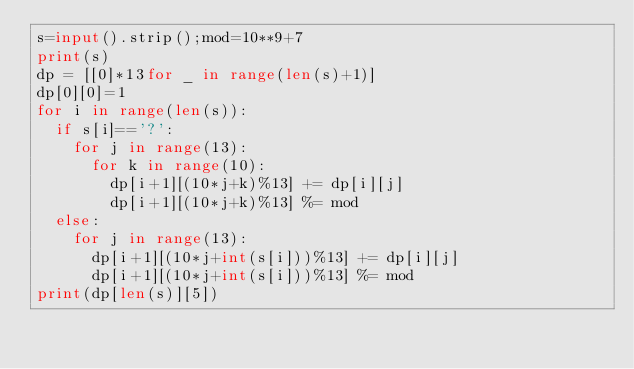<code> <loc_0><loc_0><loc_500><loc_500><_Python_>s=input().strip();mod=10**9+7
print(s)
dp = [[0]*13for _ in range(len(s)+1)]
dp[0][0]=1
for i in range(len(s)):
  if s[i]=='?':
    for j in range(13):
      for k in range(10):
        dp[i+1][(10*j+k)%13] += dp[i][j]
        dp[i+1][(10*j+k)%13] %= mod
  else:
    for j in range(13):
      dp[i+1][(10*j+int(s[i]))%13] += dp[i][j]
      dp[i+1][(10*j+int(s[i]))%13] %= mod
print(dp[len(s)][5])</code> 